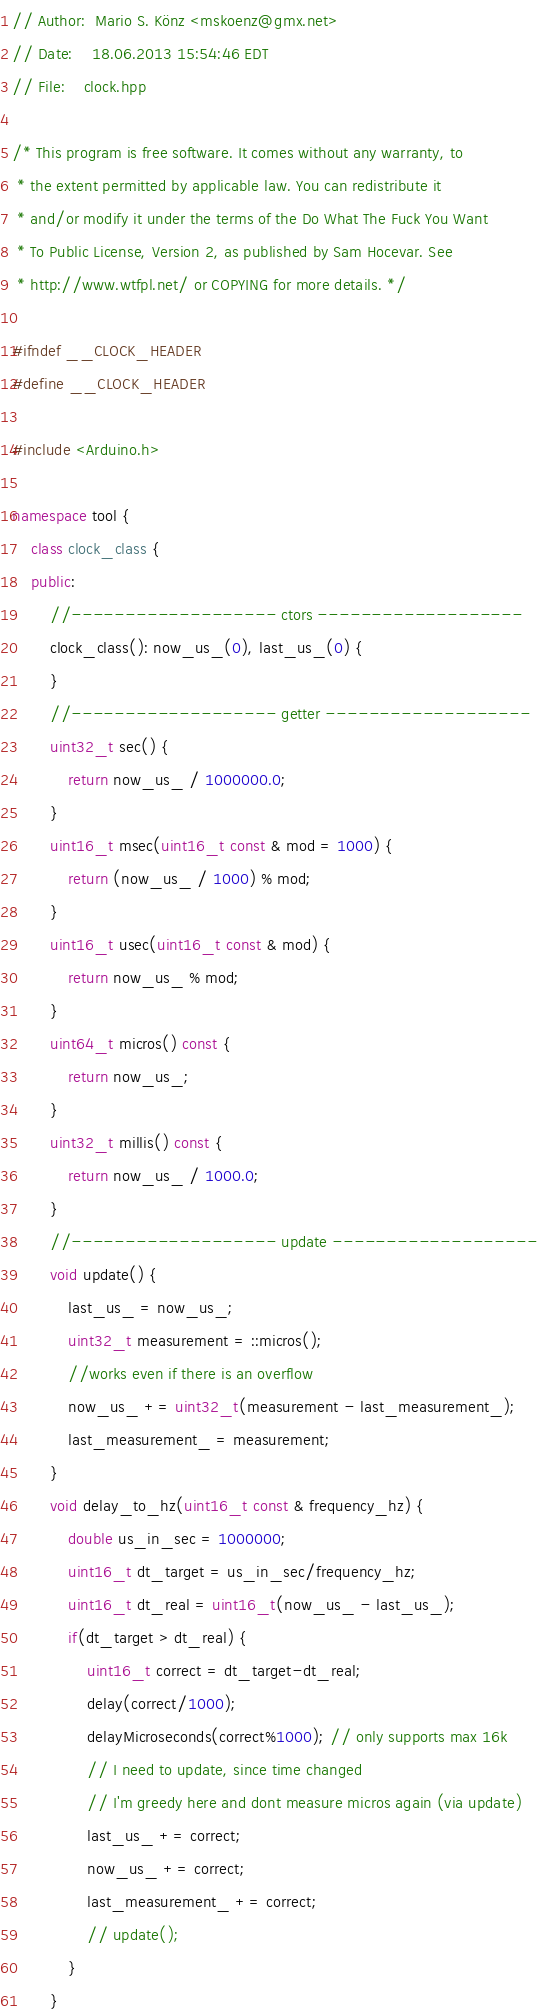<code> <loc_0><loc_0><loc_500><loc_500><_C++_>// Author:  Mario S. Könz <mskoenz@gmx.net>
// Date:    18.06.2013 15:54:46 EDT
// File:    clock.hpp

/* This program is free software. It comes without any warranty, to
 * the extent permitted by applicable law. You can redistribute it
 * and/or modify it under the terms of the Do What The Fuck You Want
 * To Public License, Version 2, as published by Sam Hocevar. See
 * http://www.wtfpl.net/ or COPYING for more details. */

#ifndef __CLOCK_HEADER
#define __CLOCK_HEADER

#include <Arduino.h>

namespace tool {
    class clock_class {
    public:
        //------------------- ctors -------------------
        clock_class(): now_us_(0), last_us_(0) {
        }
        //------------------- getter -------------------
        uint32_t sec() {
            return now_us_ / 1000000.0;
        }
        uint16_t msec(uint16_t const & mod = 1000) {
            return (now_us_ / 1000) % mod;
        }
        uint16_t usec(uint16_t const & mod) {
            return now_us_ % mod;
        }
        uint64_t micros() const {
            return now_us_;
        }
        uint32_t millis() const {
            return now_us_ / 1000.0;
        }
        //------------------- update -------------------
        void update() {
            last_us_ = now_us_;
            uint32_t measurement = ::micros();
            //works even if there is an overflow
            now_us_ += uint32_t(measurement - last_measurement_);
            last_measurement_ = measurement;
        }
        void delay_to_hz(uint16_t const & frequency_hz) {
            double us_in_sec = 1000000;
            uint16_t dt_target = us_in_sec/frequency_hz;
            uint16_t dt_real = uint16_t(now_us_ - last_us_);
            if(dt_target > dt_real) {
                uint16_t correct = dt_target-dt_real;
                delay(correct/1000);
                delayMicroseconds(correct%1000); // only supports max 16k
                // I need to update, since time changed
                // I'm greedy here and dont measure micros again (via update)
                last_us_ += correct;
                now_us_ += correct;
                last_measurement_ += correct;
                // update();
            }
        }</code> 